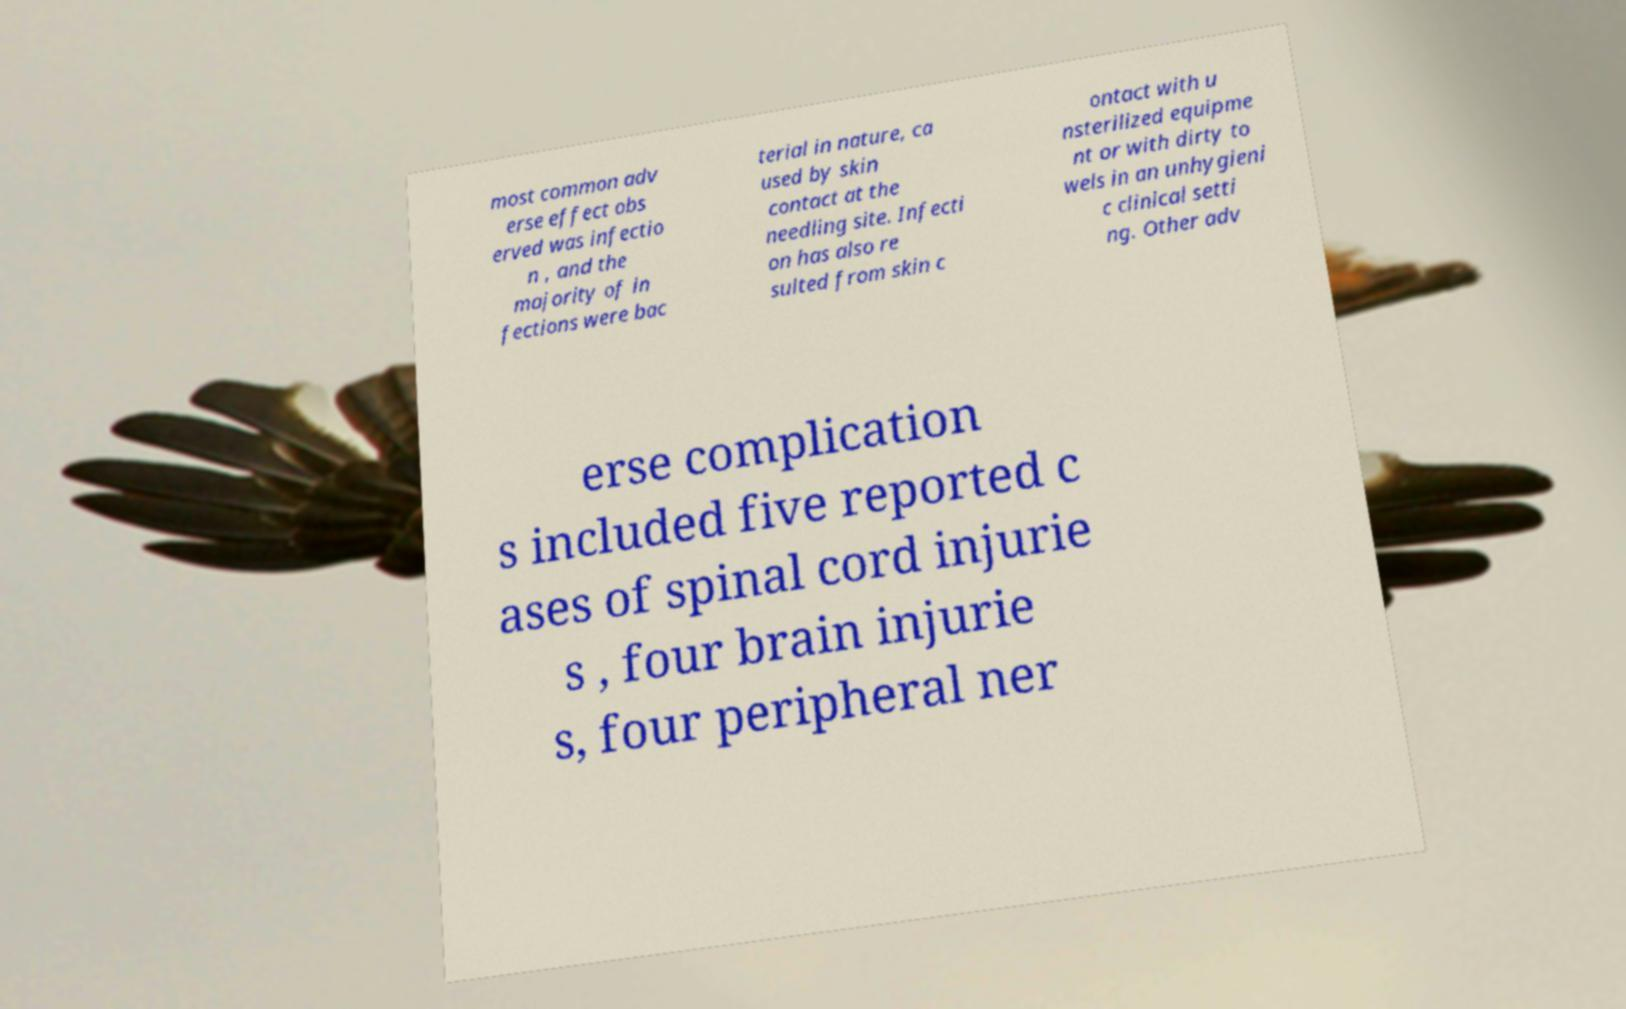Can you accurately transcribe the text from the provided image for me? most common adv erse effect obs erved was infectio n , and the majority of in fections were bac terial in nature, ca used by skin contact at the needling site. Infecti on has also re sulted from skin c ontact with u nsterilized equipme nt or with dirty to wels in an unhygieni c clinical setti ng. Other adv erse complication s included five reported c ases of spinal cord injurie s , four brain injurie s, four peripheral ner 